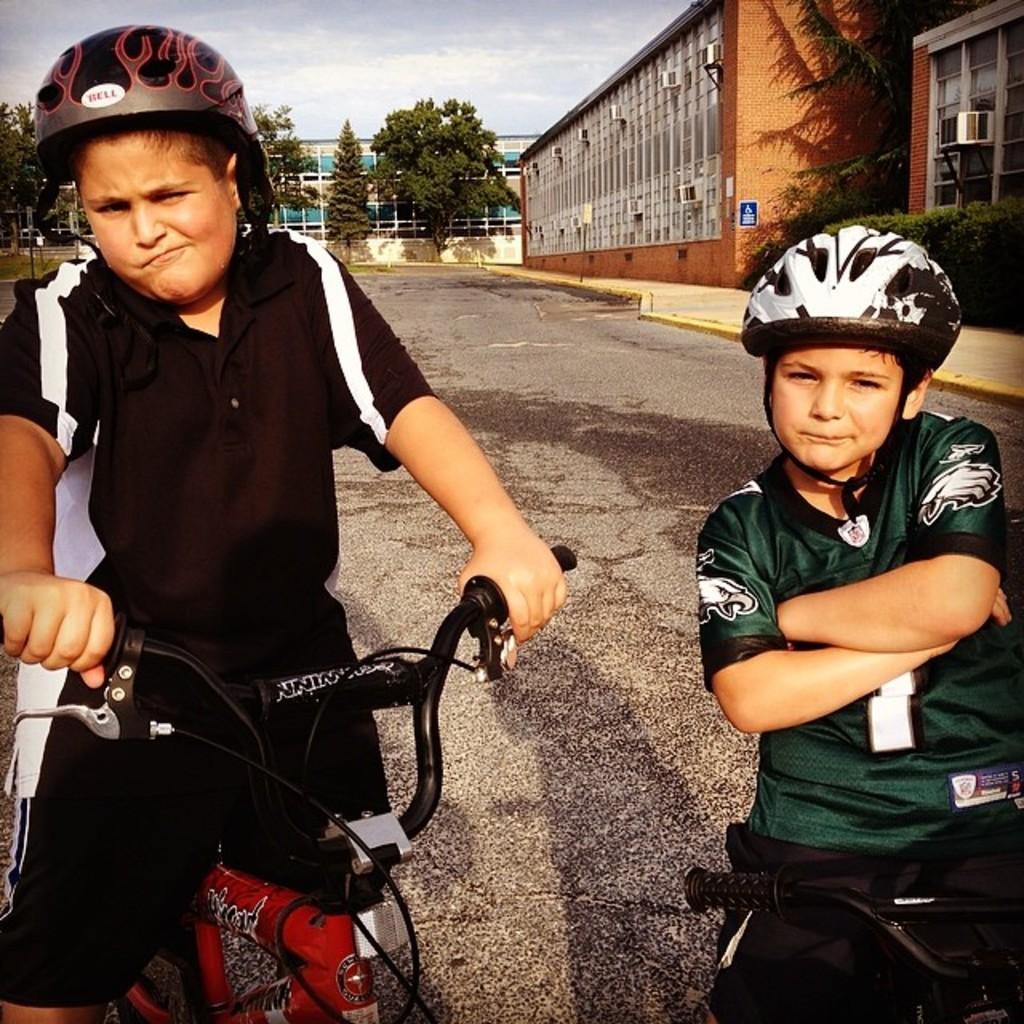Describe this image in one or two sentences. This picture describes about two boys, they are seated on the bicycle in the background we can see some shrubs, buildings and trees. 